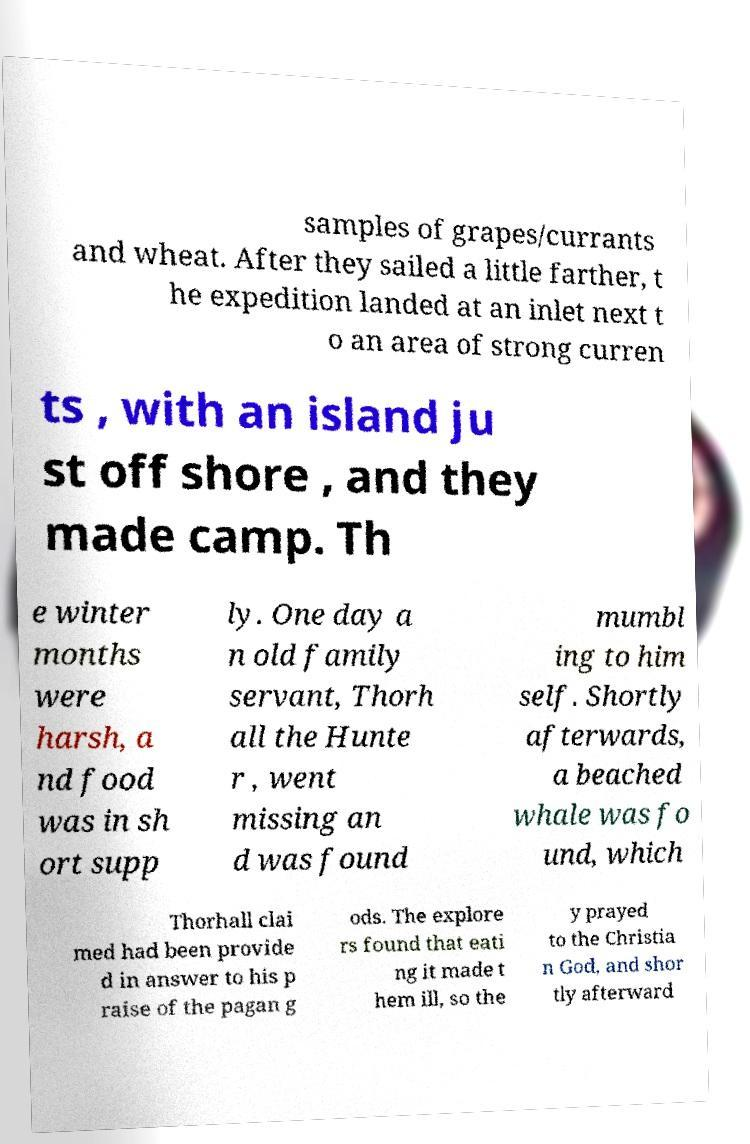Could you extract and type out the text from this image? samples of grapes/currants and wheat. After they sailed a little farther, t he expedition landed at an inlet next t o an area of strong curren ts , with an island ju st off shore , and they made camp. Th e winter months were harsh, a nd food was in sh ort supp ly. One day a n old family servant, Thorh all the Hunte r , went missing an d was found mumbl ing to him self. Shortly afterwards, a beached whale was fo und, which Thorhall clai med had been provide d in answer to his p raise of the pagan g ods. The explore rs found that eati ng it made t hem ill, so the y prayed to the Christia n God, and shor tly afterward 